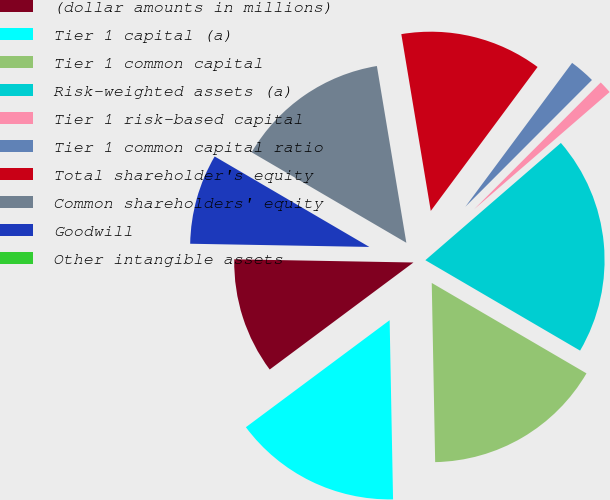Convert chart to OTSL. <chart><loc_0><loc_0><loc_500><loc_500><pie_chart><fcel>(dollar amounts in millions)<fcel>Tier 1 capital (a)<fcel>Tier 1 common capital<fcel>Risk-weighted assets (a)<fcel>Tier 1 risk-based capital<fcel>Tier 1 common capital ratio<fcel>Total shareholder's equity<fcel>Common shareholders' equity<fcel>Goodwill<fcel>Other intangible assets<nl><fcel>10.47%<fcel>15.12%<fcel>16.28%<fcel>19.77%<fcel>1.16%<fcel>2.33%<fcel>12.79%<fcel>13.95%<fcel>8.14%<fcel>0.0%<nl></chart> 